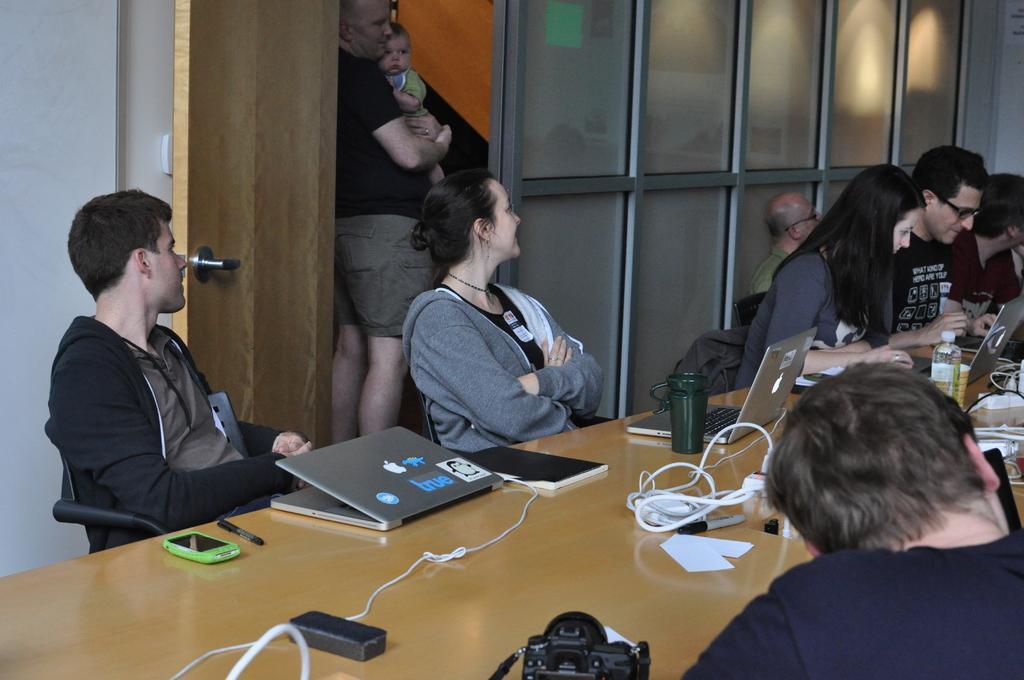In one or two sentences, can you explain what this image depicts? In this image there are a few people sitting on their chairs, in front of them there is a table. On the table there are laptops, bottles, mobile, pen, cables and a few other objects. In the background there is a wall and an open door, there is a person standing and holding a baby. 